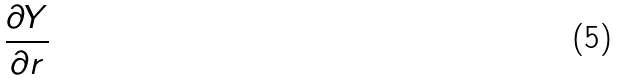Convert formula to latex. <formula><loc_0><loc_0><loc_500><loc_500>\frac { \partial Y } { \partial r }</formula> 